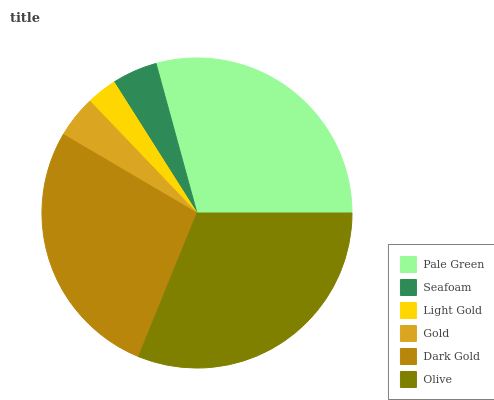Is Light Gold the minimum?
Answer yes or no. Yes. Is Olive the maximum?
Answer yes or no. Yes. Is Seafoam the minimum?
Answer yes or no. No. Is Seafoam the maximum?
Answer yes or no. No. Is Pale Green greater than Seafoam?
Answer yes or no. Yes. Is Seafoam less than Pale Green?
Answer yes or no. Yes. Is Seafoam greater than Pale Green?
Answer yes or no. No. Is Pale Green less than Seafoam?
Answer yes or no. No. Is Dark Gold the high median?
Answer yes or no. Yes. Is Seafoam the low median?
Answer yes or no. Yes. Is Olive the high median?
Answer yes or no. No. Is Light Gold the low median?
Answer yes or no. No. 